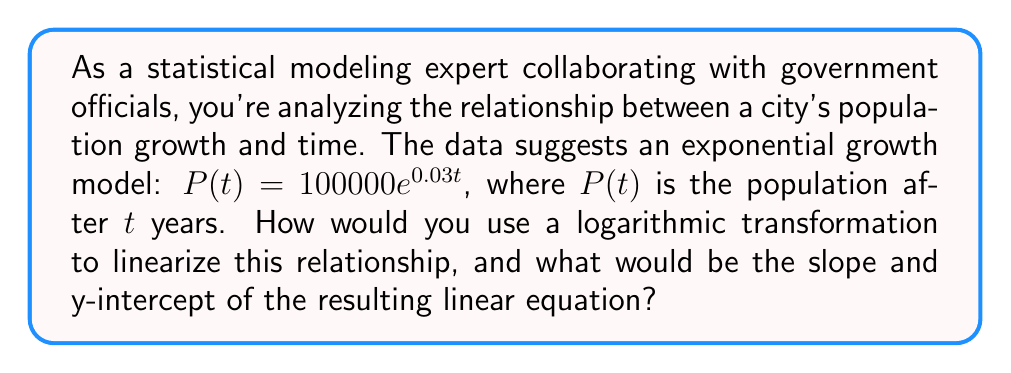Help me with this question. 1) The given exponential model is:
   $P(t) = 100000e^{0.03t}$

2) To linearize this relationship, we apply the natural logarithm to both sides:
   $\ln(P(t)) = \ln(100000e^{0.03t})$

3) Using the logarithm property $\ln(ab) = \ln(a) + \ln(b)$, we get:
   $\ln(P(t)) = \ln(100000) + \ln(e^{0.03t})$

4) Simplify using the property $\ln(e^x) = x$:
   $\ln(P(t)) = \ln(100000) + 0.03t$

5) Calculate $\ln(100000)$:
   $\ln(P(t)) = 11.51293 + 0.03t$

6) This is now in the form of a linear equation $y = mx + b$, where:
   $y = \ln(P(t))$
   $x = t$
   $m = 0.03$ (slope)
   $b = 11.51293$ (y-intercept)
Answer: Slope: 0.03, Y-intercept: 11.51293 